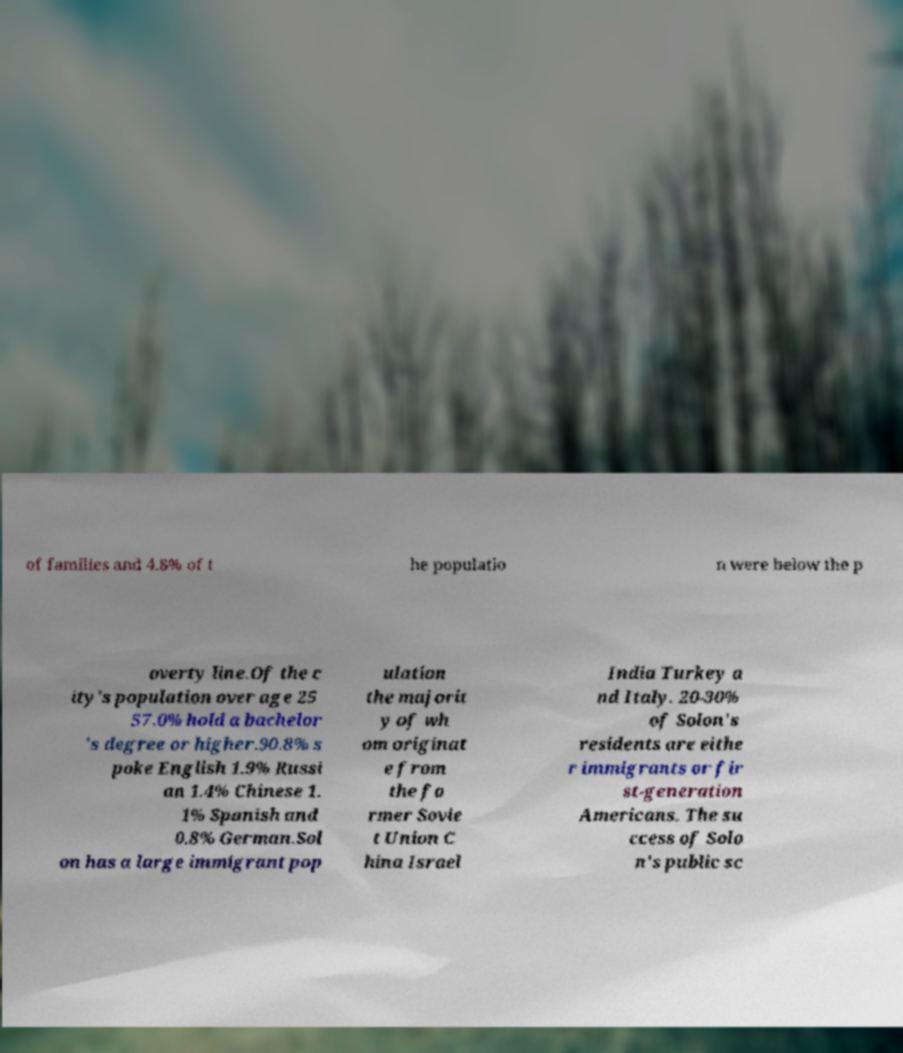Could you assist in decoding the text presented in this image and type it out clearly? of families and 4.8% of t he populatio n were below the p overty line.Of the c ity's population over age 25 57.0% hold a bachelor 's degree or higher.90.8% s poke English 1.9% Russi an 1.4% Chinese 1. 1% Spanish and 0.8% German.Sol on has a large immigrant pop ulation the majorit y of wh om originat e from the fo rmer Sovie t Union C hina Israel India Turkey a nd Italy. 20-30% of Solon's residents are eithe r immigrants or fir st-generation Americans. The su ccess of Solo n's public sc 